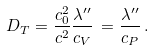Convert formula to latex. <formula><loc_0><loc_0><loc_500><loc_500>D _ { T } = \frac { c _ { 0 } ^ { 2 } } { c ^ { 2 } } \frac { \lambda ^ { \prime \prime } } { c _ { V } } \, = \frac { \lambda ^ { \prime \prime } } { c _ { P } } \, .</formula> 